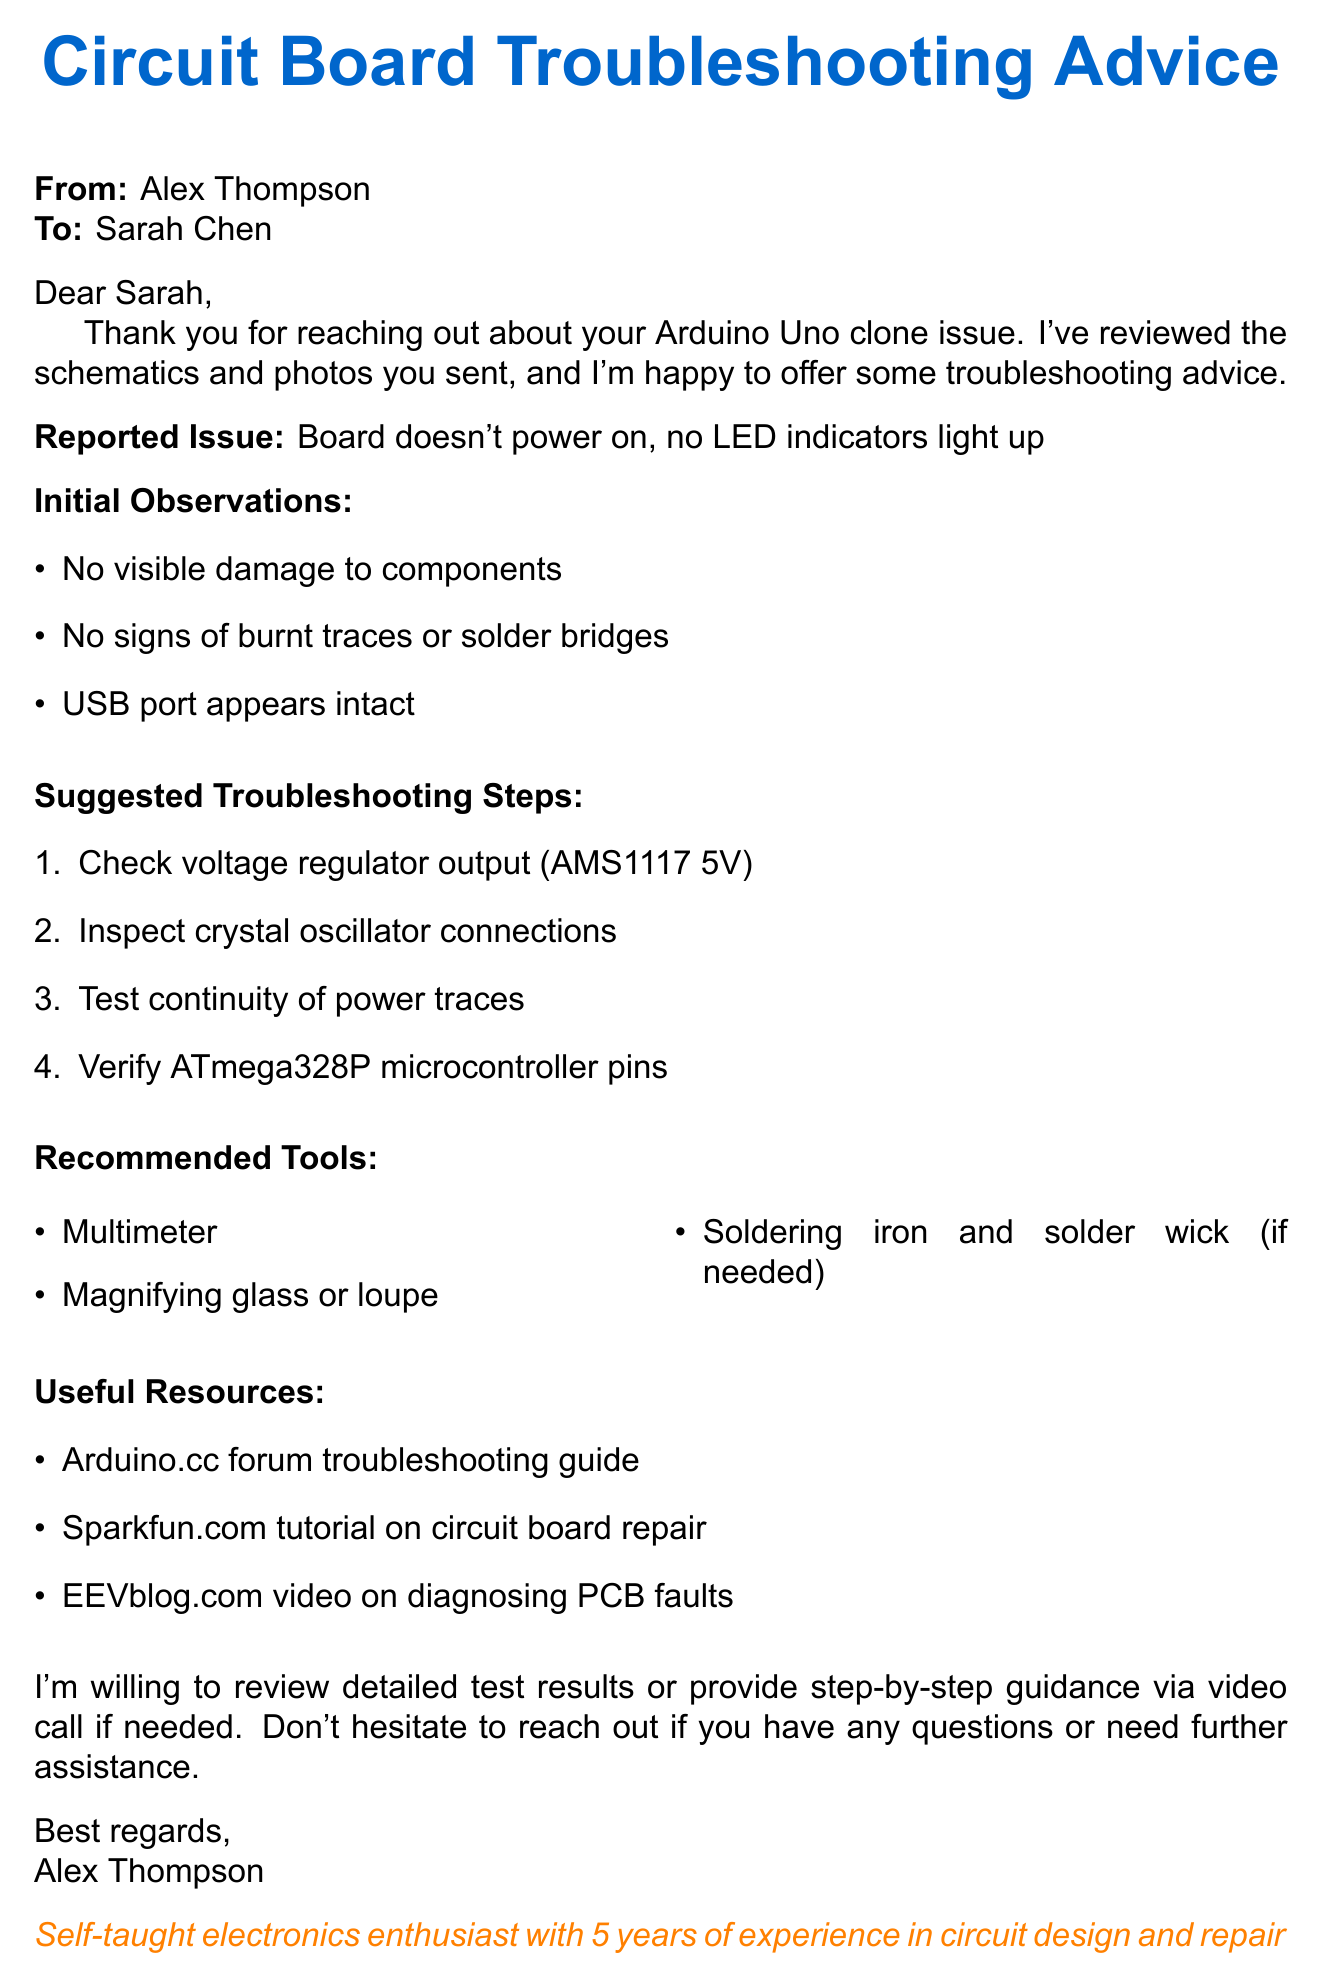What is the type of the faulty circuit board? The document states that the board in question is an Arduino Uno clone.
Answer: Arduino Uno clone Who is the sender of the email? The sender's name is given at the beginning of the document as Alex Thompson.
Answer: Alex Thompson What issue is reported with the circuit board? The document mentions that the board doesn't power on and no LED indicators light up as the reported issue.
Answer: Board doesn't power on, no LED indicators light up What is one of the suggested troubleshooting steps? The document lists several steps, one of which is to check the voltage regulator output (AMS1117 5V).
Answer: Check voltage regulator output (AMS1117 5V) What resources are recommended in the document? The document recommends checking the Arduino.cc forum troubleshooting guide, among others.
Answer: Arduino.cc forum troubleshooting guide What tools are suggested for troubleshooting? The document suggests using a multimeter, among other tools for troubleshooting.
Answer: Multimeter How many years of experience does the sender have? The sender mentions having five years of experience in circuit design and repair in the document.
Answer: 5 years What type of assistance does Alex offer? Alex offers to review detailed test results or provide step-by-step guidance via video call.
Answer: Review detailed test results or provide step-by-step guidance via video call What is the primary purpose of the email? The primary purpose of the email is to provide troubleshooting advice for the faulty circuit board.
Answer: Provide troubleshooting advice 